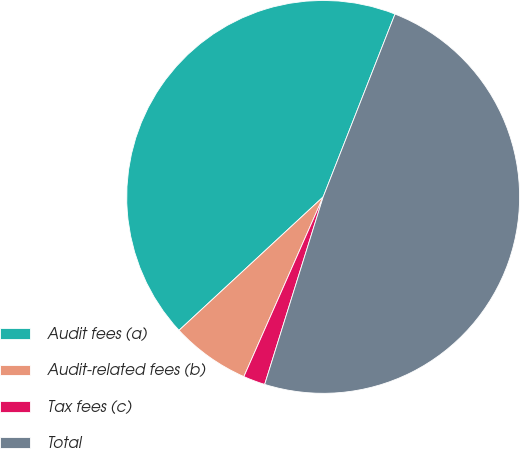Convert chart. <chart><loc_0><loc_0><loc_500><loc_500><pie_chart><fcel>Audit fees (a)<fcel>Audit-related fees (b)<fcel>Tax fees (c)<fcel>Total<nl><fcel>42.85%<fcel>6.5%<fcel>1.8%<fcel>48.86%<nl></chart> 